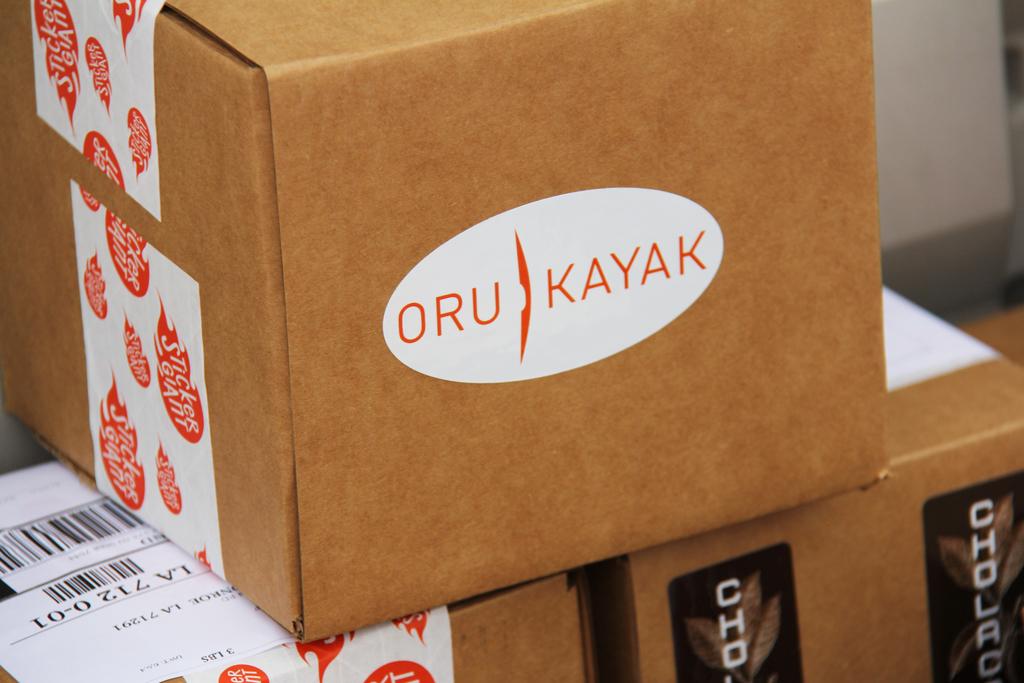Which company is this box for?
Your response must be concise. Oru kayak. What do the logos on the side of the box say?
Provide a short and direct response. Oru kayak. 